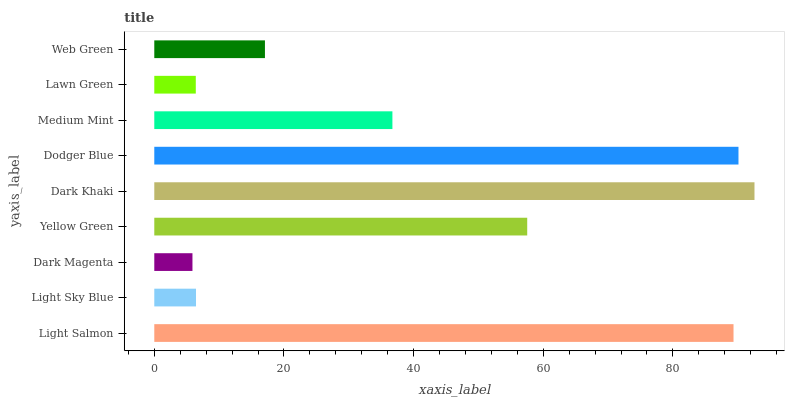Is Dark Magenta the minimum?
Answer yes or no. Yes. Is Dark Khaki the maximum?
Answer yes or no. Yes. Is Light Sky Blue the minimum?
Answer yes or no. No. Is Light Sky Blue the maximum?
Answer yes or no. No. Is Light Salmon greater than Light Sky Blue?
Answer yes or no. Yes. Is Light Sky Blue less than Light Salmon?
Answer yes or no. Yes. Is Light Sky Blue greater than Light Salmon?
Answer yes or no. No. Is Light Salmon less than Light Sky Blue?
Answer yes or no. No. Is Medium Mint the high median?
Answer yes or no. Yes. Is Medium Mint the low median?
Answer yes or no. Yes. Is Dark Magenta the high median?
Answer yes or no. No. Is Dodger Blue the low median?
Answer yes or no. No. 